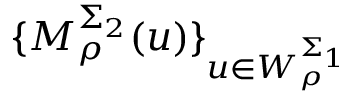<formula> <loc_0><loc_0><loc_500><loc_500>\{ M _ { \rho } ^ { \Sigma _ { 2 } } ( u ) \} _ { u \in W _ { \rho } ^ { \Sigma _ { 1 } } }</formula> 